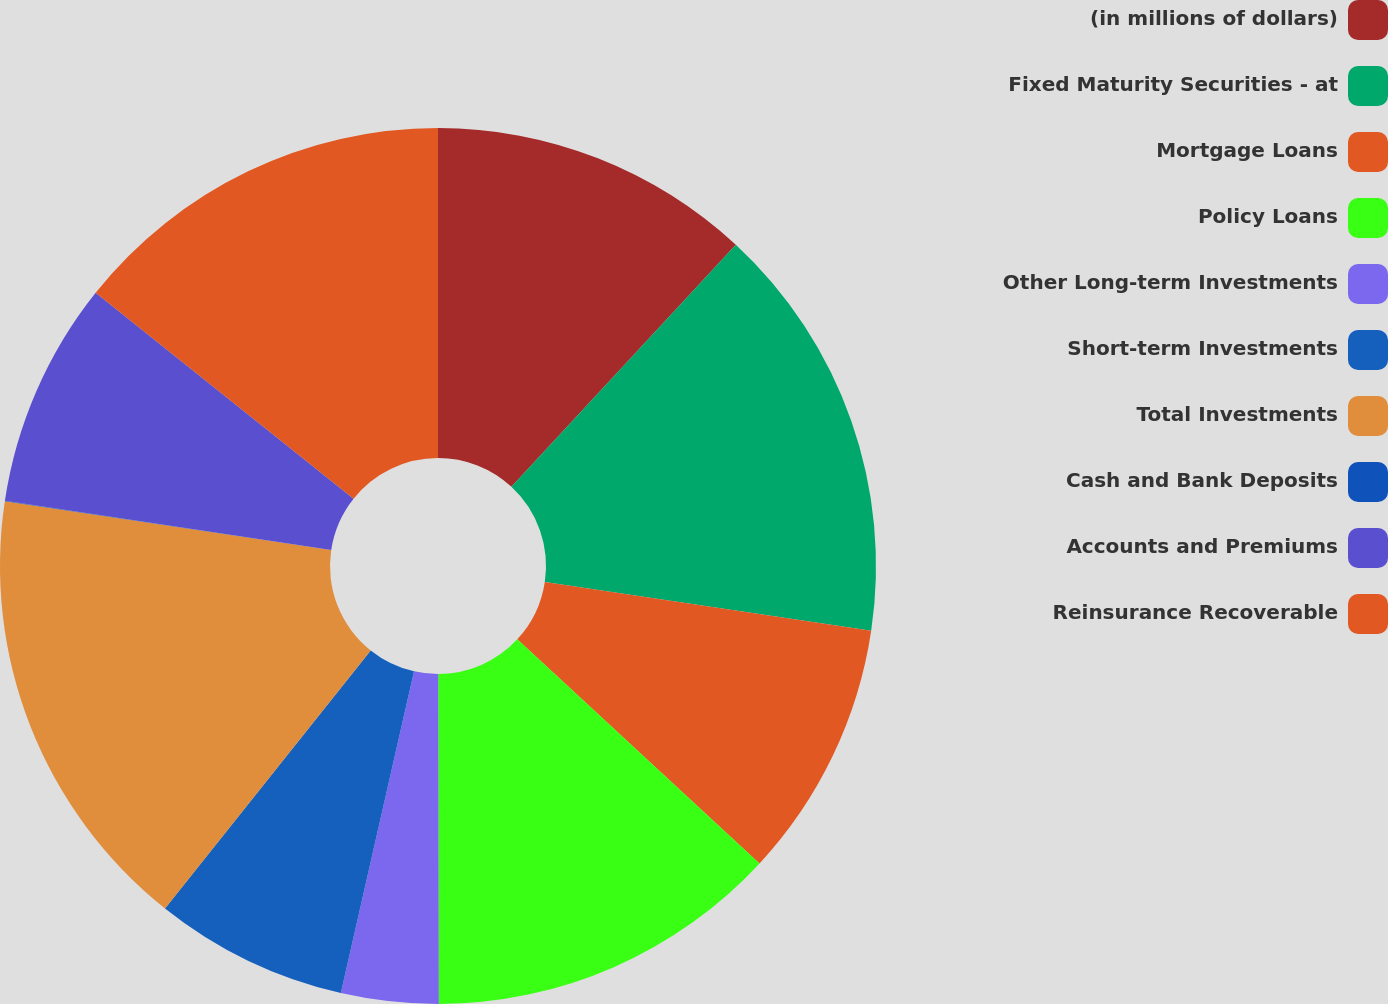Convert chart. <chart><loc_0><loc_0><loc_500><loc_500><pie_chart><fcel>(in millions of dollars)<fcel>Fixed Maturity Securities - at<fcel>Mortgage Loans<fcel>Policy Loans<fcel>Other Long-term Investments<fcel>Short-term Investments<fcel>Total Investments<fcel>Cash and Bank Deposits<fcel>Accounts and Premiums<fcel>Reinsurance Recoverable<nl><fcel>11.9%<fcel>15.46%<fcel>9.52%<fcel>13.09%<fcel>3.59%<fcel>7.15%<fcel>16.65%<fcel>0.02%<fcel>8.34%<fcel>14.28%<nl></chart> 